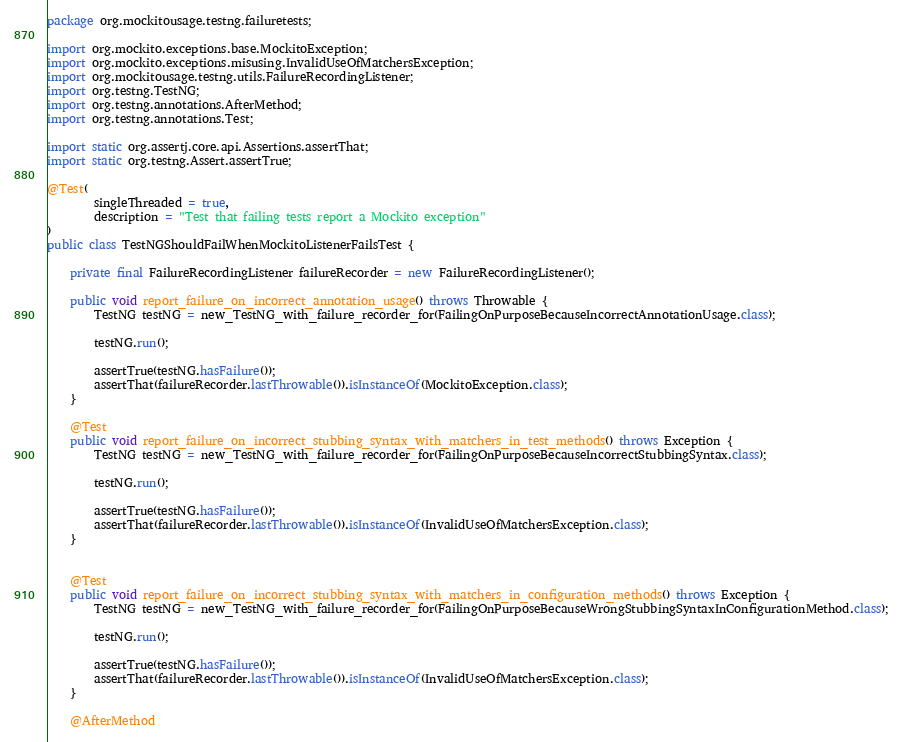<code> <loc_0><loc_0><loc_500><loc_500><_Java_>package org.mockitousage.testng.failuretests;

import org.mockito.exceptions.base.MockitoException;
import org.mockito.exceptions.misusing.InvalidUseOfMatchersException;
import org.mockitousage.testng.utils.FailureRecordingListener;
import org.testng.TestNG;
import org.testng.annotations.AfterMethod;
import org.testng.annotations.Test;

import static org.assertj.core.api.Assertions.assertThat;
import static org.testng.Assert.assertTrue;

@Test(
        singleThreaded = true,
        description = "Test that failing tests report a Mockito exception"
)
public class TestNGShouldFailWhenMockitoListenerFailsTest {

    private final FailureRecordingListener failureRecorder = new FailureRecordingListener();

    public void report_failure_on_incorrect_annotation_usage() throws Throwable {
        TestNG testNG = new_TestNG_with_failure_recorder_for(FailingOnPurposeBecauseIncorrectAnnotationUsage.class);

        testNG.run();

        assertTrue(testNG.hasFailure());
        assertThat(failureRecorder.lastThrowable()).isInstanceOf(MockitoException.class);
    }

    @Test
    public void report_failure_on_incorrect_stubbing_syntax_with_matchers_in_test_methods() throws Exception {
        TestNG testNG = new_TestNG_with_failure_recorder_for(FailingOnPurposeBecauseIncorrectStubbingSyntax.class);

        testNG.run();

        assertTrue(testNG.hasFailure());
        assertThat(failureRecorder.lastThrowable()).isInstanceOf(InvalidUseOfMatchersException.class);
    }


    @Test
    public void report_failure_on_incorrect_stubbing_syntax_with_matchers_in_configuration_methods() throws Exception {
        TestNG testNG = new_TestNG_with_failure_recorder_for(FailingOnPurposeBecauseWrongStubbingSyntaxInConfigurationMethod.class);

        testNG.run();

        assertTrue(testNG.hasFailure());
        assertThat(failureRecorder.lastThrowable()).isInstanceOf(InvalidUseOfMatchersException.class);
    }

    @AfterMethod</code> 